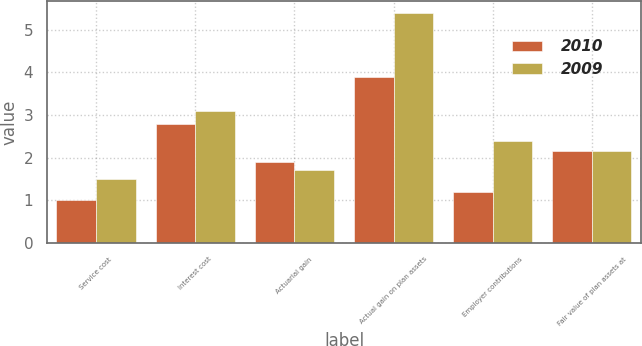Convert chart to OTSL. <chart><loc_0><loc_0><loc_500><loc_500><stacked_bar_chart><ecel><fcel>Service cost<fcel>Interest cost<fcel>Actuarial gain<fcel>Actual gain on plan assets<fcel>Employer contributions<fcel>Fair value of plan assets at<nl><fcel>2010<fcel>1<fcel>2.8<fcel>1.9<fcel>3.9<fcel>1.2<fcel>2.15<nl><fcel>2009<fcel>1.5<fcel>3.1<fcel>1.7<fcel>5.4<fcel>2.4<fcel>2.15<nl></chart> 